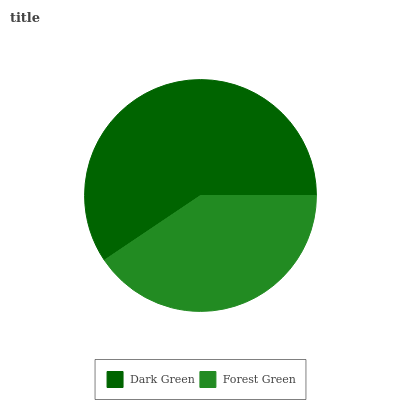Is Forest Green the minimum?
Answer yes or no. Yes. Is Dark Green the maximum?
Answer yes or no. Yes. Is Forest Green the maximum?
Answer yes or no. No. Is Dark Green greater than Forest Green?
Answer yes or no. Yes. Is Forest Green less than Dark Green?
Answer yes or no. Yes. Is Forest Green greater than Dark Green?
Answer yes or no. No. Is Dark Green less than Forest Green?
Answer yes or no. No. Is Dark Green the high median?
Answer yes or no. Yes. Is Forest Green the low median?
Answer yes or no. Yes. Is Forest Green the high median?
Answer yes or no. No. Is Dark Green the low median?
Answer yes or no. No. 